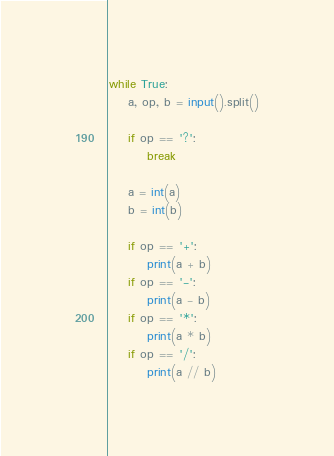<code> <loc_0><loc_0><loc_500><loc_500><_Python_>while True:
    a, op, b = input().split()
    
    if op == '?':
        break
    
    a = int(a)
    b = int(b)
    
    if op == '+':
        print(a + b)
    if op == '-':
        print(a - b)
    if op == '*':
        print(a * b)
    if op == '/':
        print(a // b)
</code> 